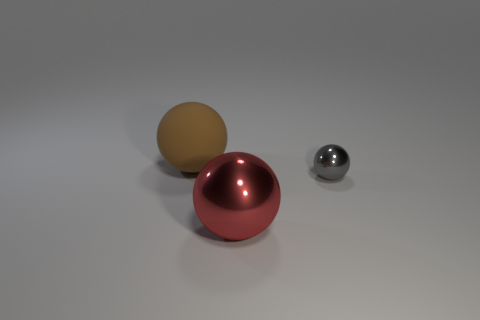Is there any other thing that is the same size as the gray shiny object?
Ensure brevity in your answer.  No. Do the ball to the right of the large red thing and the big thing behind the gray metallic object have the same material?
Your answer should be very brief. No. What shape is the object that is in front of the big matte object and on the left side of the tiny object?
Your response must be concise. Sphere. Is there any other thing that has the same material as the brown thing?
Give a very brief answer. No. There is a ball that is both on the left side of the small gray thing and in front of the brown rubber thing; what material is it made of?
Your answer should be compact. Metal. The gray object that is made of the same material as the red sphere is what shape?
Provide a succinct answer. Sphere. Is there any other thing that is the same color as the large metal object?
Make the answer very short. No. Is the number of brown rubber things that are behind the small metallic ball greater than the number of tiny yellow matte cubes?
Your answer should be very brief. Yes. What material is the gray thing?
Offer a very short reply. Metal. How many matte balls have the same size as the red metal ball?
Provide a short and direct response. 1. 